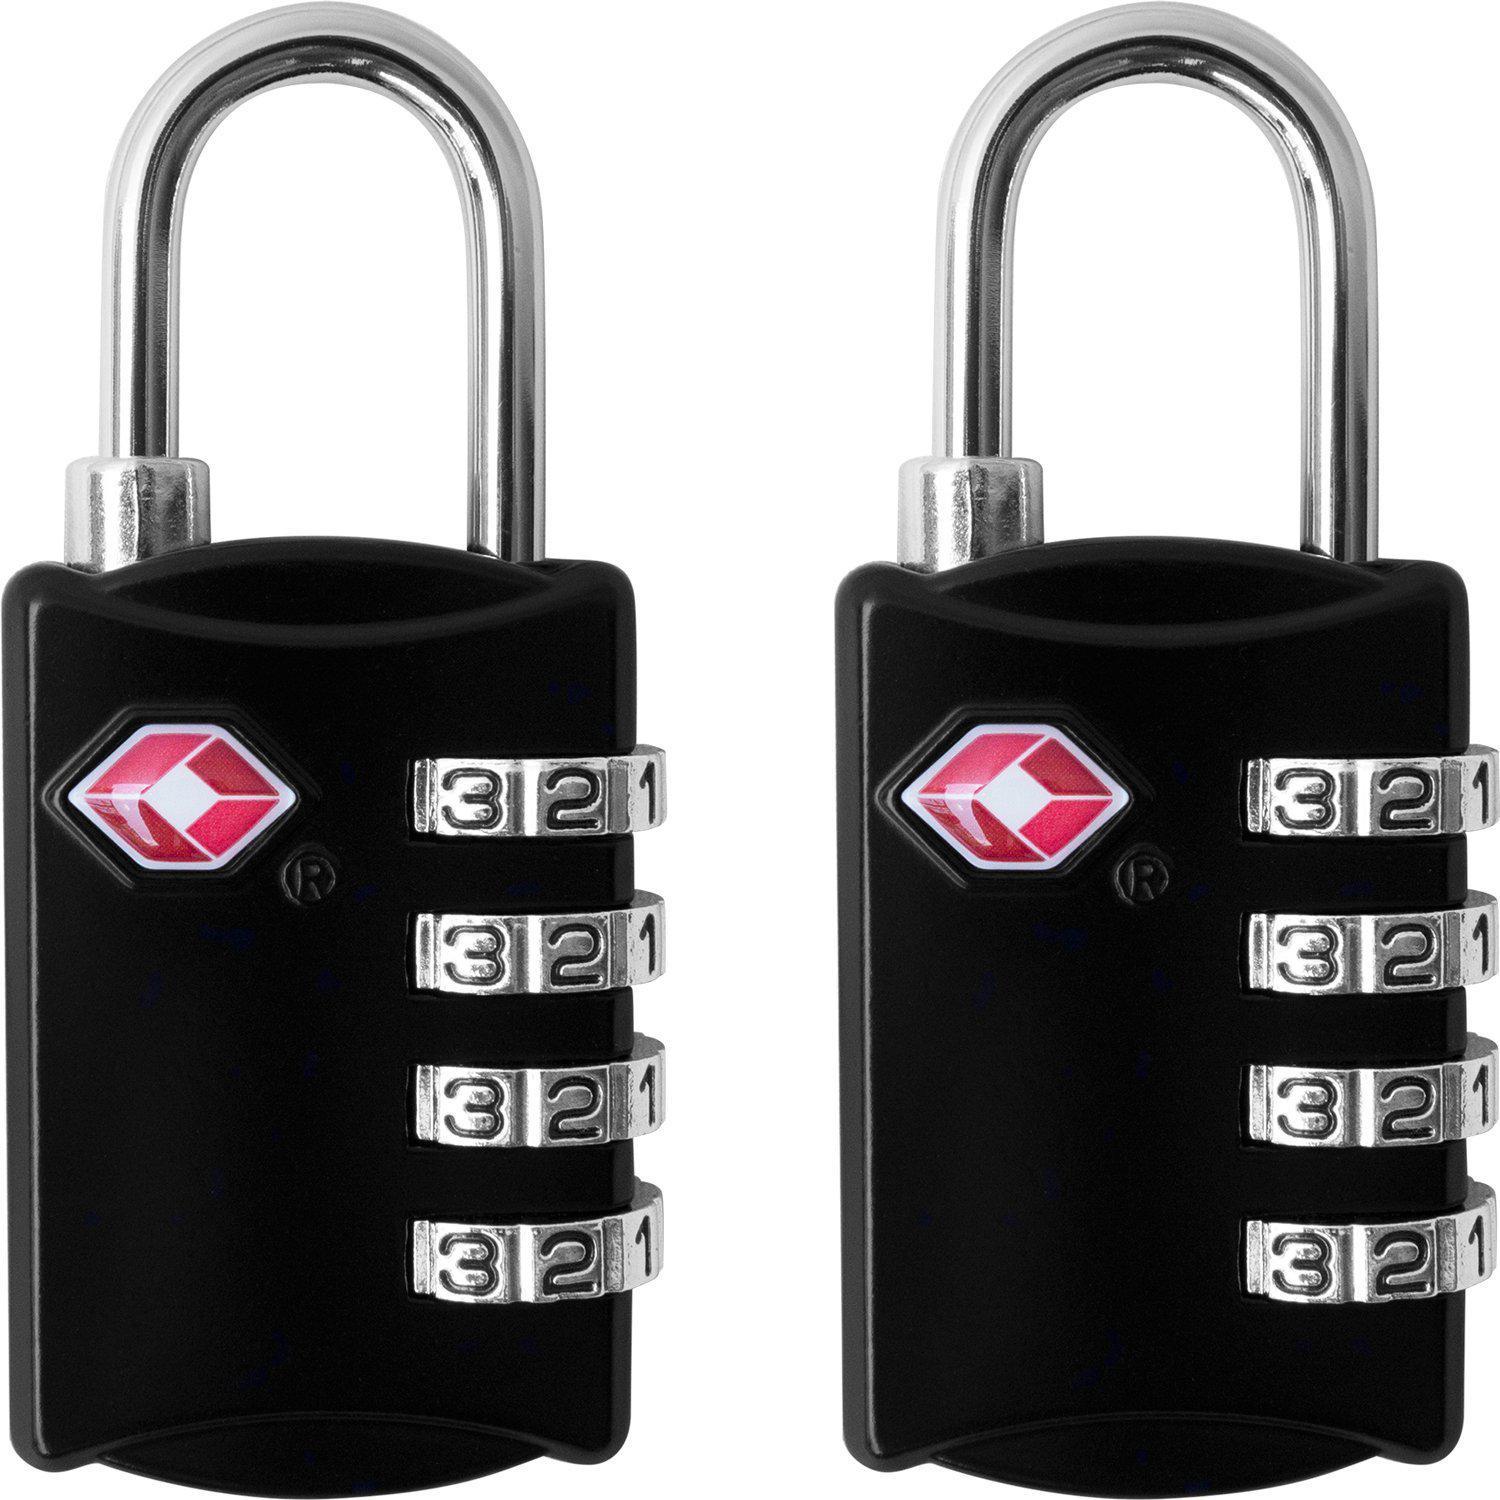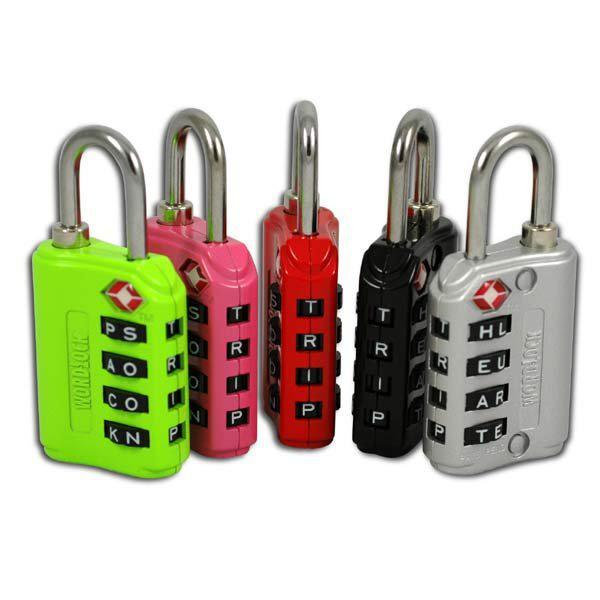The first image is the image on the left, the second image is the image on the right. Examine the images to the left and right. Is the description "One image has items other than one or more locks." accurate? Answer yes or no. No. 